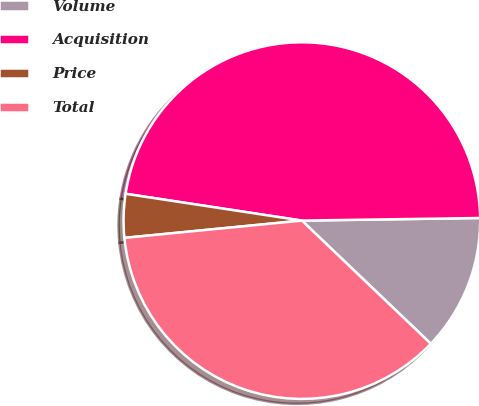Convert chart. <chart><loc_0><loc_0><loc_500><loc_500><pie_chart><fcel>Volume<fcel>Acquisition<fcel>Price<fcel>Total<nl><fcel>12.37%<fcel>47.37%<fcel>3.95%<fcel>36.32%<nl></chart> 